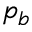<formula> <loc_0><loc_0><loc_500><loc_500>p _ { b }</formula> 